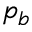<formula> <loc_0><loc_0><loc_500><loc_500>p _ { b }</formula> 